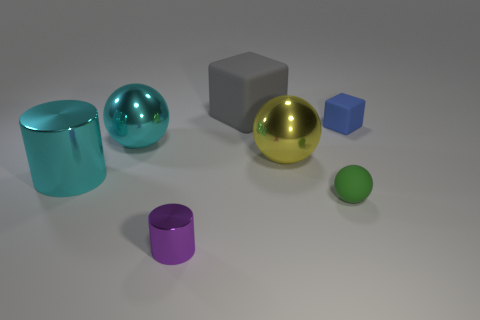Subtract all large cyan balls. How many balls are left? 2 Add 3 small blocks. How many objects exist? 10 Subtract all cylinders. How many objects are left? 5 Add 5 large yellow objects. How many large yellow objects exist? 6 Subtract 0 purple spheres. How many objects are left? 7 Subtract all purple balls. Subtract all purple blocks. How many balls are left? 3 Subtract all metal blocks. Subtract all rubber things. How many objects are left? 4 Add 6 small green rubber things. How many small green rubber things are left? 7 